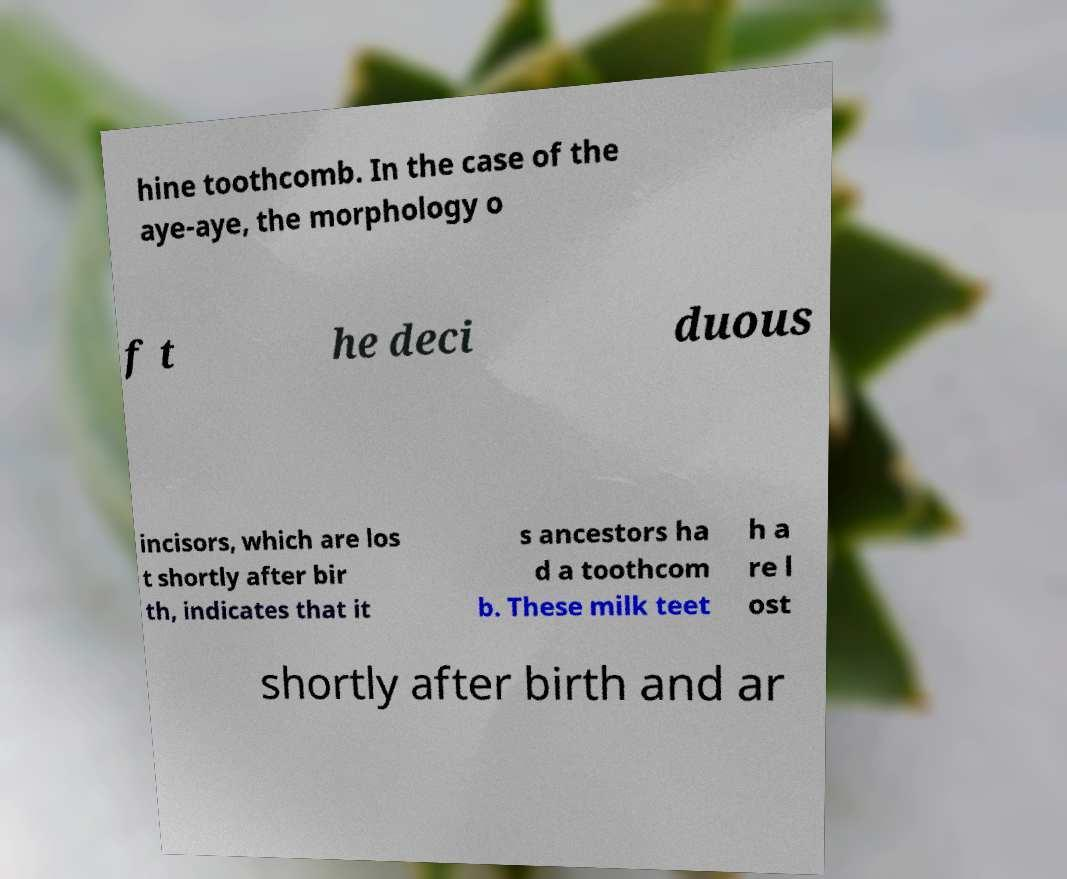Could you assist in decoding the text presented in this image and type it out clearly? hine toothcomb. In the case of the aye-aye, the morphology o f t he deci duous incisors, which are los t shortly after bir th, indicates that it s ancestors ha d a toothcom b. These milk teet h a re l ost shortly after birth and ar 